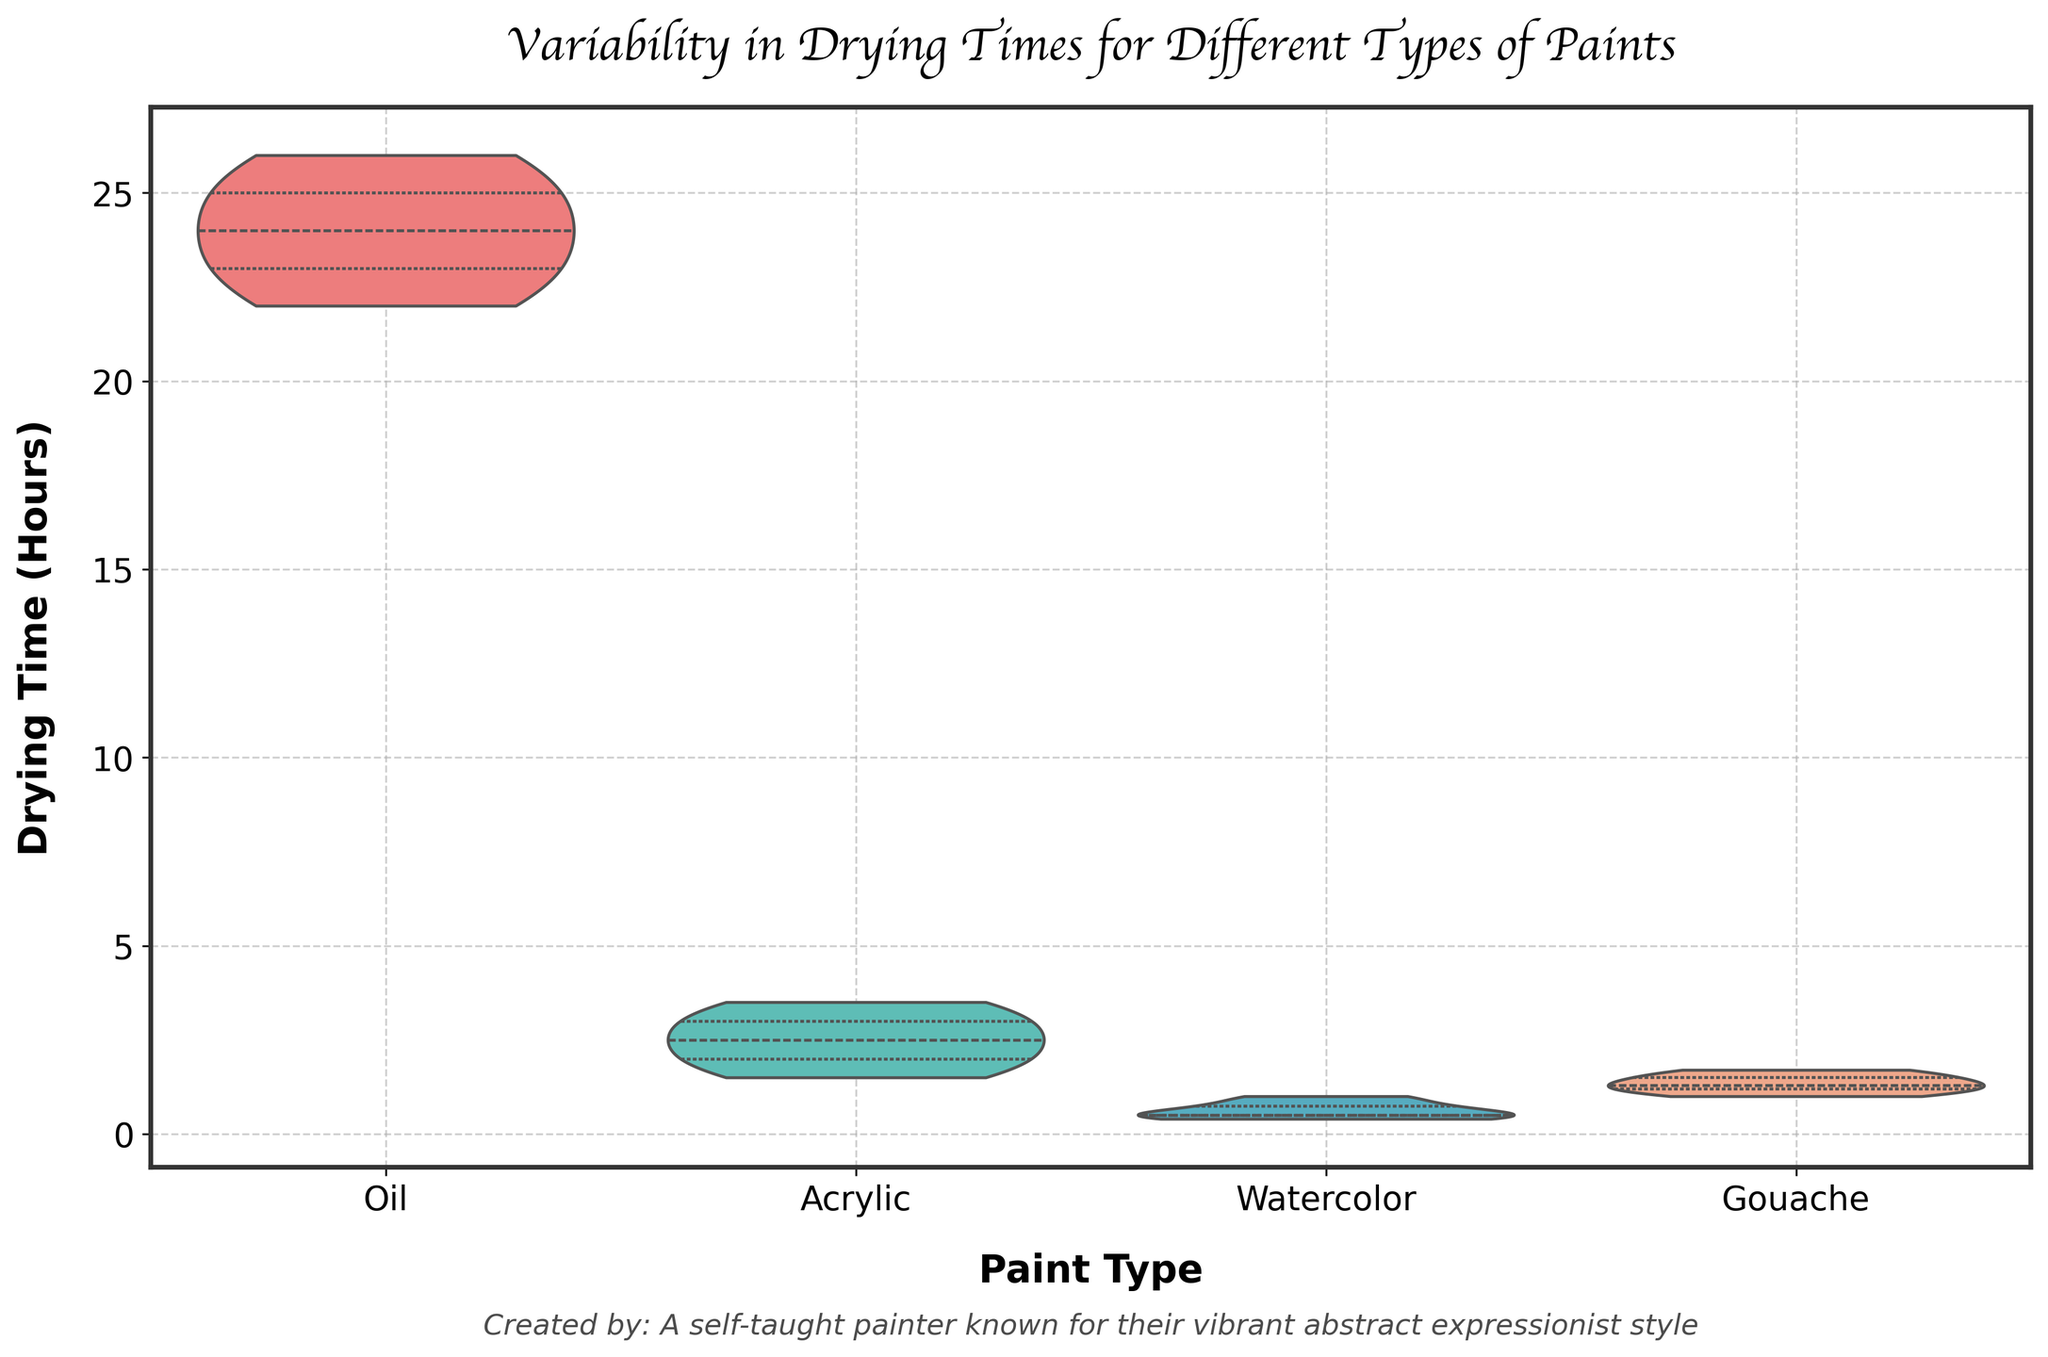What types of paints are compared in the figure? There are four types of paints shown: Oil, Acrylic, Watercolor, and Gouache.
Answer: Oil, Acrylic, Watercolor, Gouache How does the median drying time of Oil paint compare to Gouache paint? For Oil paint, the median drying time appears to be around 24 hours. For Gouache paint, the median is around 1.3 hours. Comparatively, Oil paint's median is much higher.
Answer: Oil paint's median drying time is higher Which paint type has the greatest variability in drying times? The width of the violin plot at various levels indicates the variability. Oil paint shows the largest spread of drying times, indicating the greatest variability.
Answer: Oil What is the approximate range of drying times for Acrylic paints? The drying times for Acrylic paints range from about 1.5 to 3.5 hours, as seen from the top and bottom edges of the violin plot.
Answer: 1.5 to 3.5 hours Is the median drying time of Watercolor paint greater than the lower quartile of Acrylic paint? The lower quartile of Acrylic paint is around 2 hours. The median of Watercolor paint falls between 0.5 and 0.75 hours. Therefore, the median of Watercolor is less.
Answer: No Which paint type has the fastest drying time? The shortest drying time value on the axis corresponds to Watercolor paint, showing drying times as low as 0.4 hours.
Answer: Watercolor Among all paint types, which has the least variability in drying times? The least variability is indicated by the narrowest parts of the violin plot. Watercolor shows the least spread, suggesting it has the least variability.
Answer: Watercolor What's the interquartile range (IQR) for Gouache paints? The IQR is calculated from the 25th percentile to the 75th percentile. For Gouache paints, these values are approximately 1.2 and 1.5 hours, thus the IQR is 1.5 - 1.2 = 0.3 hours.
Answer: 0.3 hours 